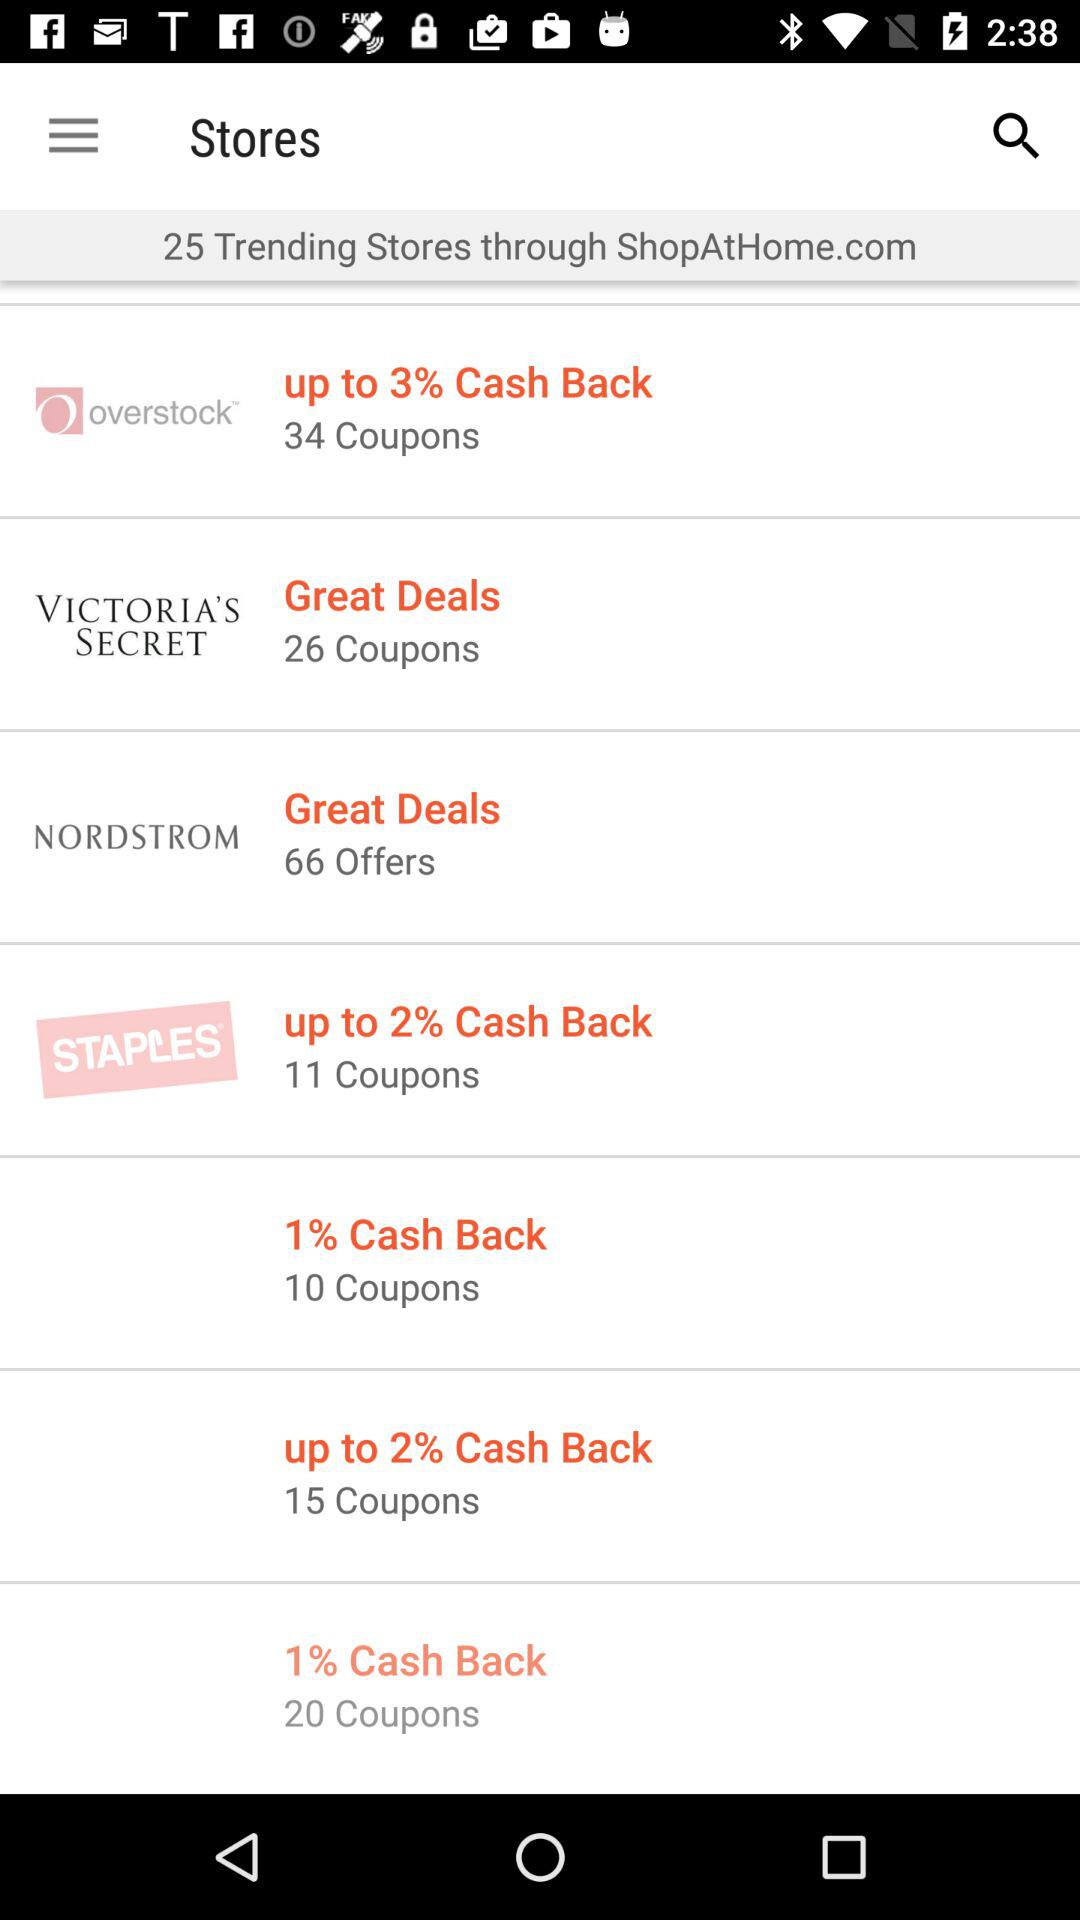What is the website? The website is ShopAtHome.com. 